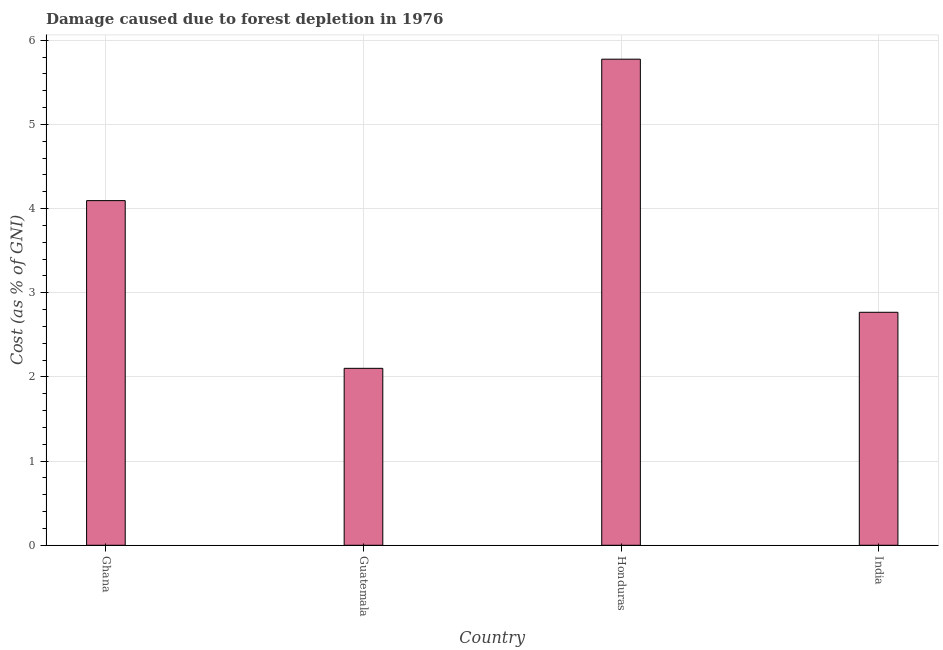Does the graph contain any zero values?
Provide a succinct answer. No. Does the graph contain grids?
Ensure brevity in your answer.  Yes. What is the title of the graph?
Make the answer very short. Damage caused due to forest depletion in 1976. What is the label or title of the Y-axis?
Make the answer very short. Cost (as % of GNI). What is the damage caused due to forest depletion in Ghana?
Your answer should be compact. 4.1. Across all countries, what is the maximum damage caused due to forest depletion?
Offer a very short reply. 5.78. Across all countries, what is the minimum damage caused due to forest depletion?
Make the answer very short. 2.1. In which country was the damage caused due to forest depletion maximum?
Your answer should be very brief. Honduras. In which country was the damage caused due to forest depletion minimum?
Offer a very short reply. Guatemala. What is the sum of the damage caused due to forest depletion?
Your answer should be compact. 14.74. What is the difference between the damage caused due to forest depletion in Guatemala and India?
Your answer should be compact. -0.67. What is the average damage caused due to forest depletion per country?
Provide a succinct answer. 3.69. What is the median damage caused due to forest depletion?
Ensure brevity in your answer.  3.43. In how many countries, is the damage caused due to forest depletion greater than 5.4 %?
Provide a short and direct response. 1. What is the ratio of the damage caused due to forest depletion in Honduras to that in India?
Keep it short and to the point. 2.09. Is the damage caused due to forest depletion in Ghana less than that in Guatemala?
Provide a short and direct response. No. What is the difference between the highest and the second highest damage caused due to forest depletion?
Give a very brief answer. 1.68. Is the sum of the damage caused due to forest depletion in Honduras and India greater than the maximum damage caused due to forest depletion across all countries?
Ensure brevity in your answer.  Yes. What is the difference between the highest and the lowest damage caused due to forest depletion?
Your response must be concise. 3.67. Are all the bars in the graph horizontal?
Provide a short and direct response. No. How many countries are there in the graph?
Your answer should be very brief. 4. What is the Cost (as % of GNI) in Ghana?
Offer a very short reply. 4.1. What is the Cost (as % of GNI) of Guatemala?
Ensure brevity in your answer.  2.1. What is the Cost (as % of GNI) of Honduras?
Give a very brief answer. 5.78. What is the Cost (as % of GNI) in India?
Provide a short and direct response. 2.77. What is the difference between the Cost (as % of GNI) in Ghana and Guatemala?
Ensure brevity in your answer.  1.99. What is the difference between the Cost (as % of GNI) in Ghana and Honduras?
Keep it short and to the point. -1.68. What is the difference between the Cost (as % of GNI) in Ghana and India?
Ensure brevity in your answer.  1.33. What is the difference between the Cost (as % of GNI) in Guatemala and Honduras?
Provide a succinct answer. -3.67. What is the difference between the Cost (as % of GNI) in Guatemala and India?
Keep it short and to the point. -0.67. What is the difference between the Cost (as % of GNI) in Honduras and India?
Your response must be concise. 3.01. What is the ratio of the Cost (as % of GNI) in Ghana to that in Guatemala?
Your answer should be very brief. 1.95. What is the ratio of the Cost (as % of GNI) in Ghana to that in Honduras?
Ensure brevity in your answer.  0.71. What is the ratio of the Cost (as % of GNI) in Ghana to that in India?
Provide a short and direct response. 1.48. What is the ratio of the Cost (as % of GNI) in Guatemala to that in Honduras?
Give a very brief answer. 0.36. What is the ratio of the Cost (as % of GNI) in Guatemala to that in India?
Your answer should be very brief. 0.76. What is the ratio of the Cost (as % of GNI) in Honduras to that in India?
Ensure brevity in your answer.  2.09. 